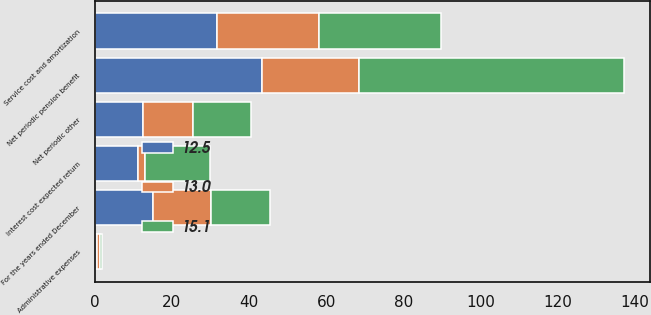Convert chart to OTSL. <chart><loc_0><loc_0><loc_500><loc_500><stacked_bar_chart><ecel><fcel>For the years ended December<fcel>Service cost and amortization<fcel>Interest cost expected return<fcel>Administrative expenses<fcel>Net periodic pension benefit<fcel>Net periodic other<nl><fcel>13<fcel>15.1<fcel>26.3<fcel>1.9<fcel>0.8<fcel>25.2<fcel>13<nl><fcel>12.5<fcel>15.1<fcel>31.8<fcel>11.2<fcel>0.7<fcel>43.3<fcel>12.5<nl><fcel>15.1<fcel>15.1<fcel>31.6<fcel>16.7<fcel>0.5<fcel>68.5<fcel>15.1<nl></chart> 